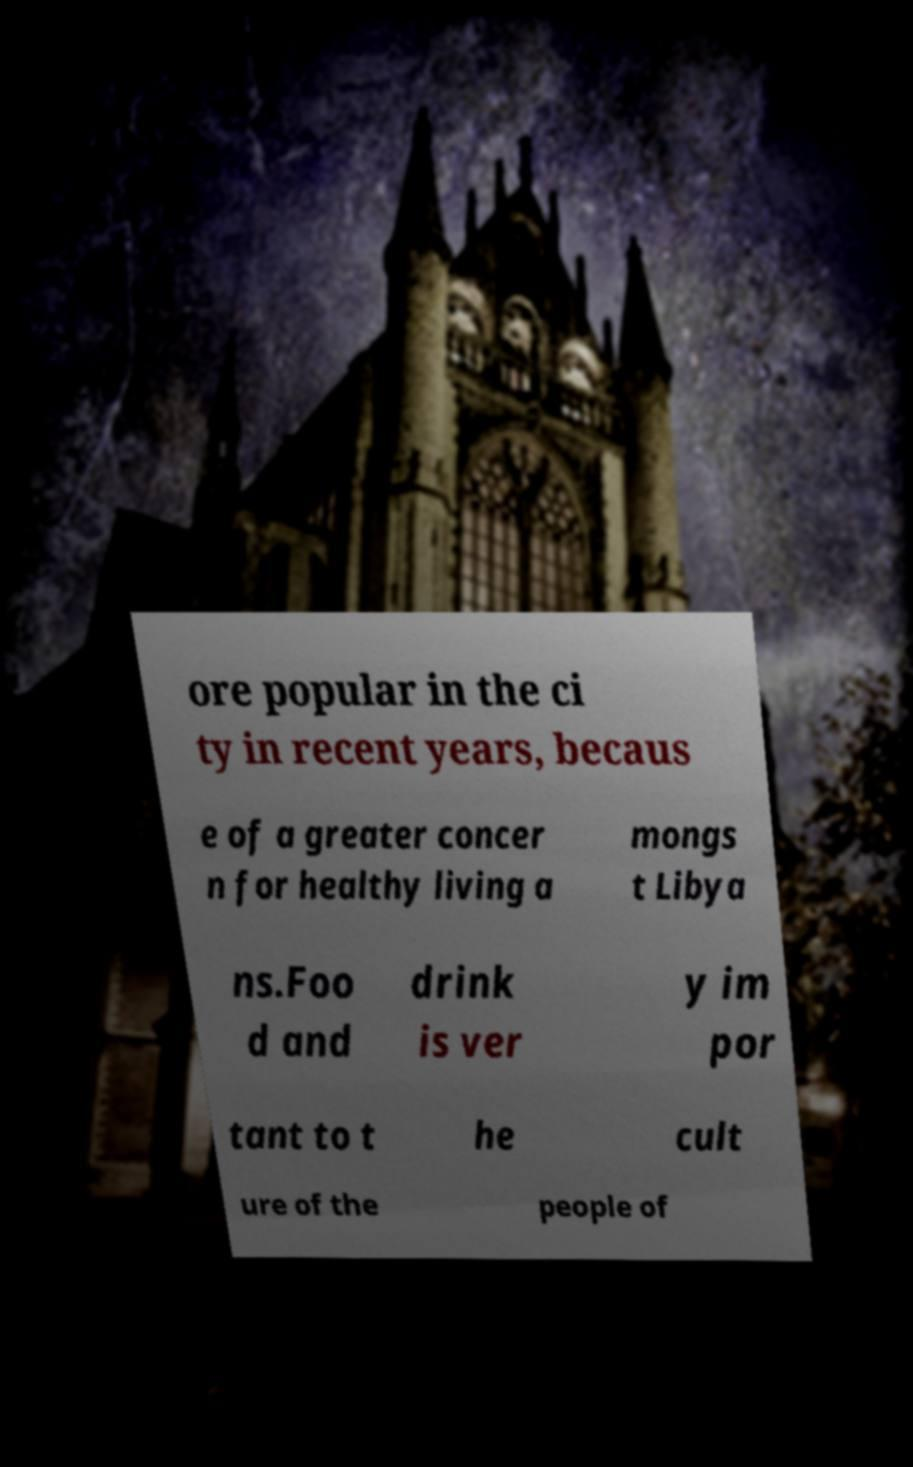Could you extract and type out the text from this image? ore popular in the ci ty in recent years, becaus e of a greater concer n for healthy living a mongs t Libya ns.Foo d and drink is ver y im por tant to t he cult ure of the people of 